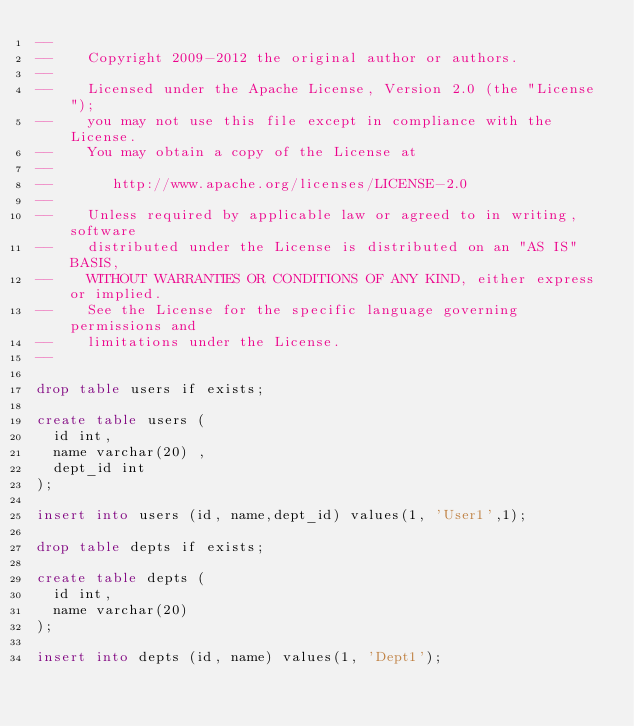<code> <loc_0><loc_0><loc_500><loc_500><_SQL_>--
--    Copyright 2009-2012 the original author or authors.
--
--    Licensed under the Apache License, Version 2.0 (the "License");
--    you may not use this file except in compliance with the License.
--    You may obtain a copy of the License at
--
--       http://www.apache.org/licenses/LICENSE-2.0
--
--    Unless required by applicable law or agreed to in writing, software
--    distributed under the License is distributed on an "AS IS" BASIS,
--    WITHOUT WARRANTIES OR CONDITIONS OF ANY KIND, either express or implied.
--    See the License for the specific language governing permissions and
--    limitations under the License.
--

drop table users if exists;

create table users (
  id int,
  name varchar(20) ,
  dept_id int
);

insert into users (id, name,dept_id) values(1, 'User1',1);

drop table depts if exists;

create table depts (
  id int,
  name varchar(20)
);

insert into depts (id, name) values(1, 'Dept1');

</code> 